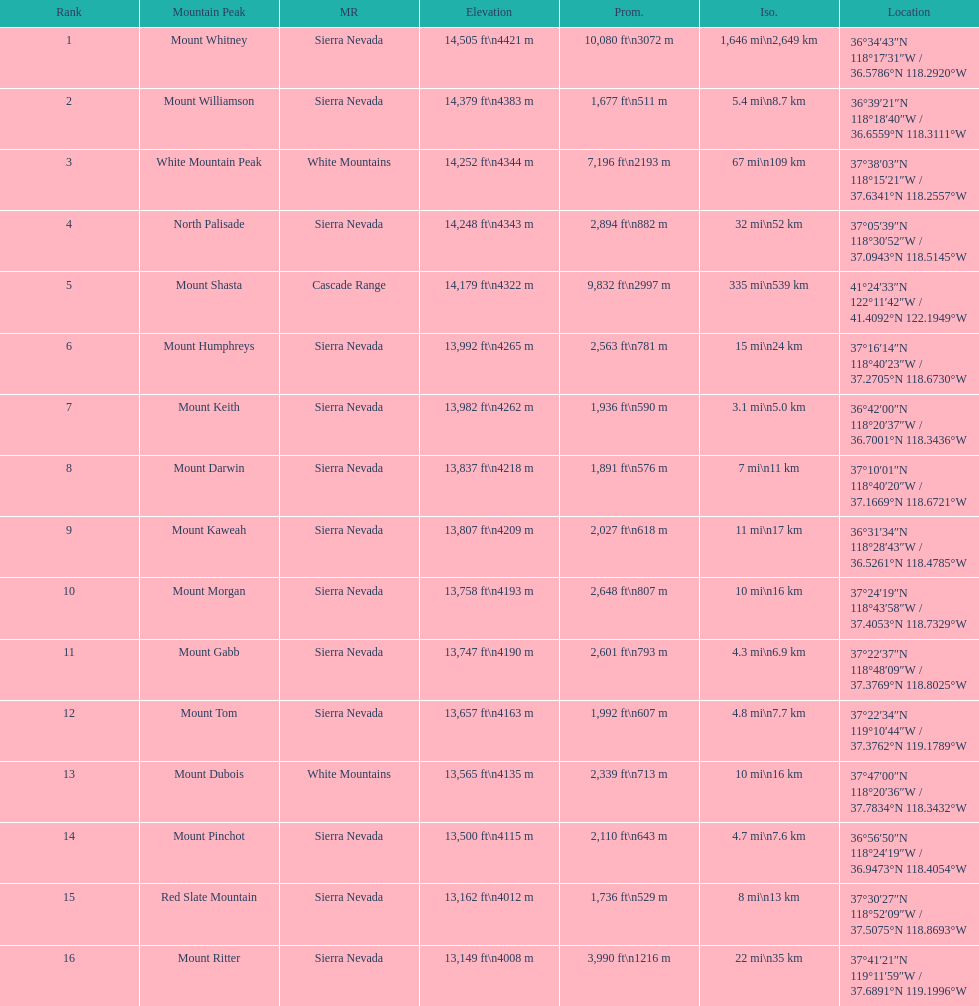Which mountain peak is no higher than 13,149 ft? Mount Ritter. 